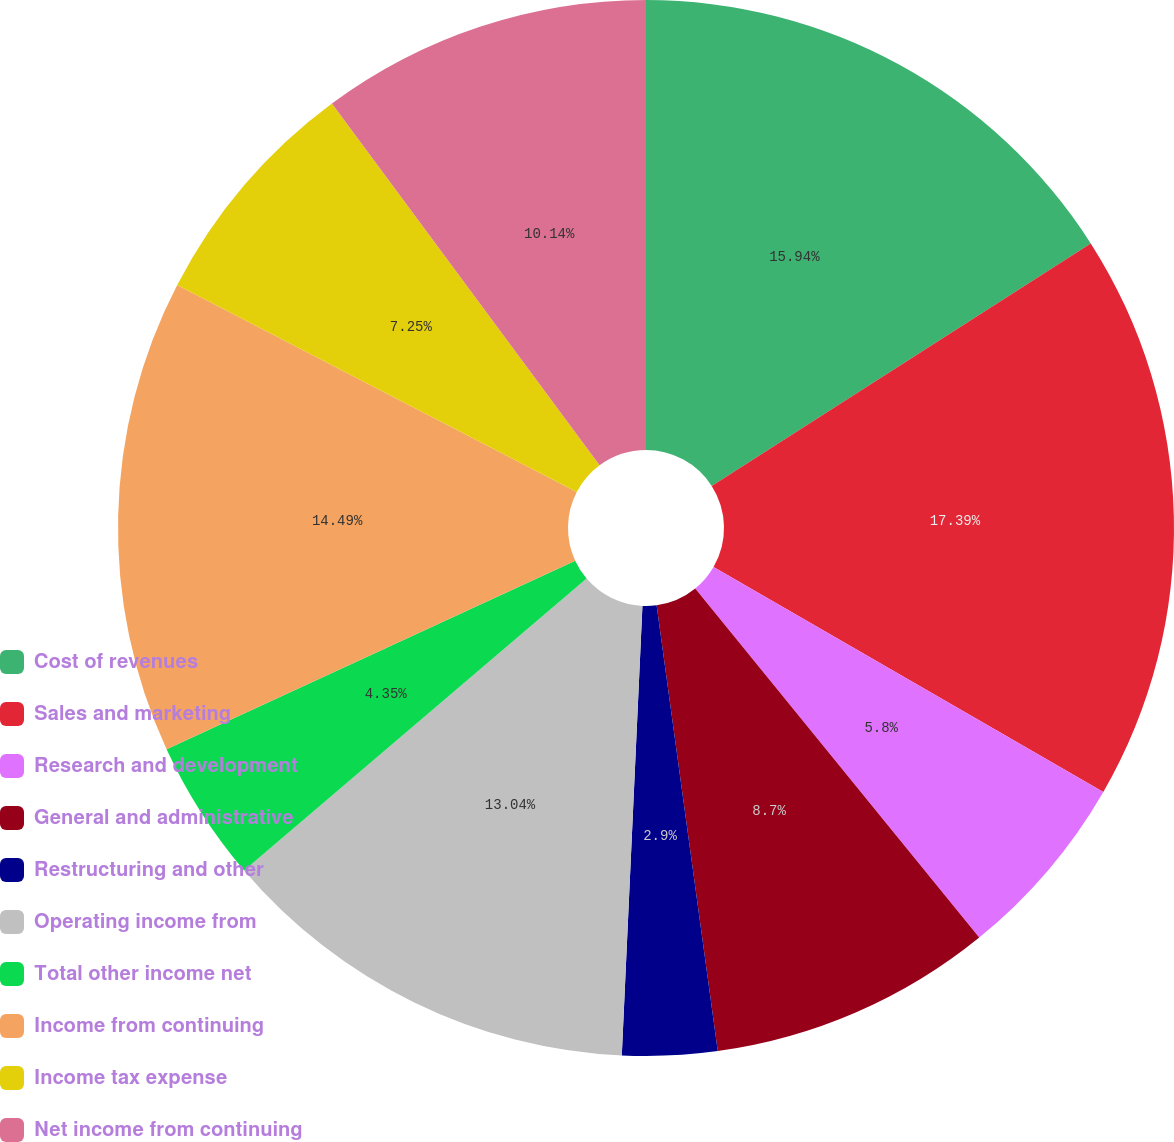<chart> <loc_0><loc_0><loc_500><loc_500><pie_chart><fcel>Cost of revenues<fcel>Sales and marketing<fcel>Research and development<fcel>General and administrative<fcel>Restructuring and other<fcel>Operating income from<fcel>Total other income net<fcel>Income from continuing<fcel>Income tax expense<fcel>Net income from continuing<nl><fcel>15.94%<fcel>17.39%<fcel>5.8%<fcel>8.7%<fcel>2.9%<fcel>13.04%<fcel>4.35%<fcel>14.49%<fcel>7.25%<fcel>10.14%<nl></chart> 